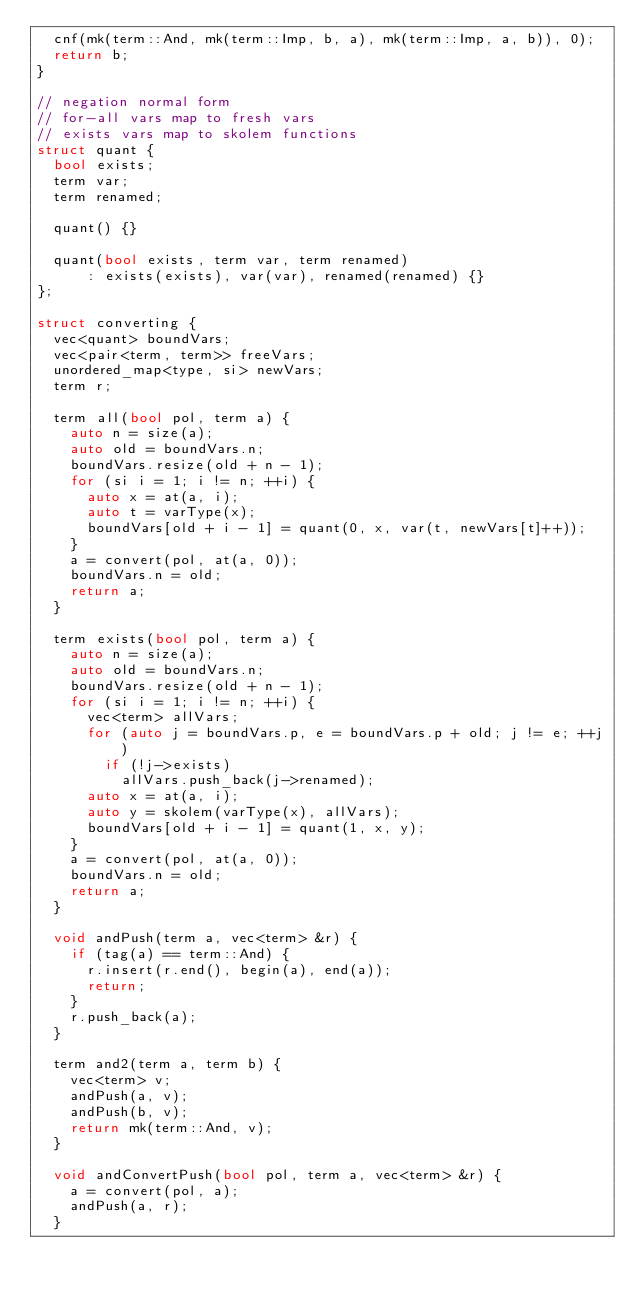Convert code to text. <code><loc_0><loc_0><loc_500><loc_500><_C++_>  cnf(mk(term::And, mk(term::Imp, b, a), mk(term::Imp, a, b)), 0);
  return b;
}

// negation normal form
// for-all vars map to fresh vars
// exists vars map to skolem functions
struct quant {
  bool exists;
  term var;
  term renamed;

  quant() {}

  quant(bool exists, term var, term renamed)
      : exists(exists), var(var), renamed(renamed) {}
};

struct converting {
  vec<quant> boundVars;
  vec<pair<term, term>> freeVars;
  unordered_map<type, si> newVars;
  term r;

  term all(bool pol, term a) {
    auto n = size(a);
    auto old = boundVars.n;
    boundVars.resize(old + n - 1);
    for (si i = 1; i != n; ++i) {
      auto x = at(a, i);
      auto t = varType(x);
      boundVars[old + i - 1] = quant(0, x, var(t, newVars[t]++));
    }
    a = convert(pol, at(a, 0));
    boundVars.n = old;
    return a;
  }

  term exists(bool pol, term a) {
    auto n = size(a);
    auto old = boundVars.n;
    boundVars.resize(old + n - 1);
    for (si i = 1; i != n; ++i) {
      vec<term> allVars;
      for (auto j = boundVars.p, e = boundVars.p + old; j != e; ++j)
        if (!j->exists)
          allVars.push_back(j->renamed);
      auto x = at(a, i);
      auto y = skolem(varType(x), allVars);
      boundVars[old + i - 1] = quant(1, x, y);
    }
    a = convert(pol, at(a, 0));
    boundVars.n = old;
    return a;
  }

  void andPush(term a, vec<term> &r) {
    if (tag(a) == term::And) {
      r.insert(r.end(), begin(a), end(a));
      return;
    }
    r.push_back(a);
  }

  term and2(term a, term b) {
    vec<term> v;
    andPush(a, v);
    andPush(b, v);
    return mk(term::And, v);
  }

  void andConvertPush(bool pol, term a, vec<term> &r) {
    a = convert(pol, a);
    andPush(a, r);
  }
</code> 